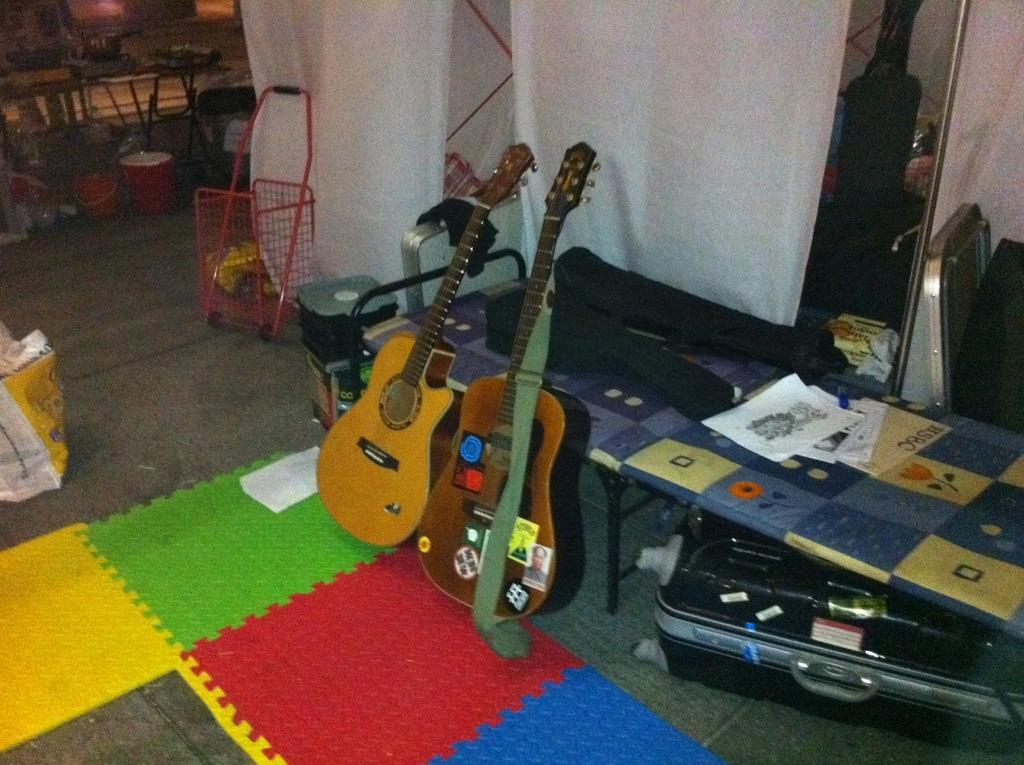What type of musical instruments can be seen in the image? There are guitars in the image. What object is present that might be used for carrying items? There is a briefcase in the image. What type of furniture is visible in the image? There are tables in the image. What items can be seen on the table? There are books on the table. What surface is visible in the image? There is a floor in the image. What container is present in the image? There is a bucket in the image. How many dolls are sitting on the guitars in the image? There are no dolls present in the image; it features guitars, a briefcase, tables, books, a floor, and a bucket. What type of store can be seen in the background of the image? There is no store visible in the image; it is focused on the guitars, briefcase, tables, books, floor, and bucket. 